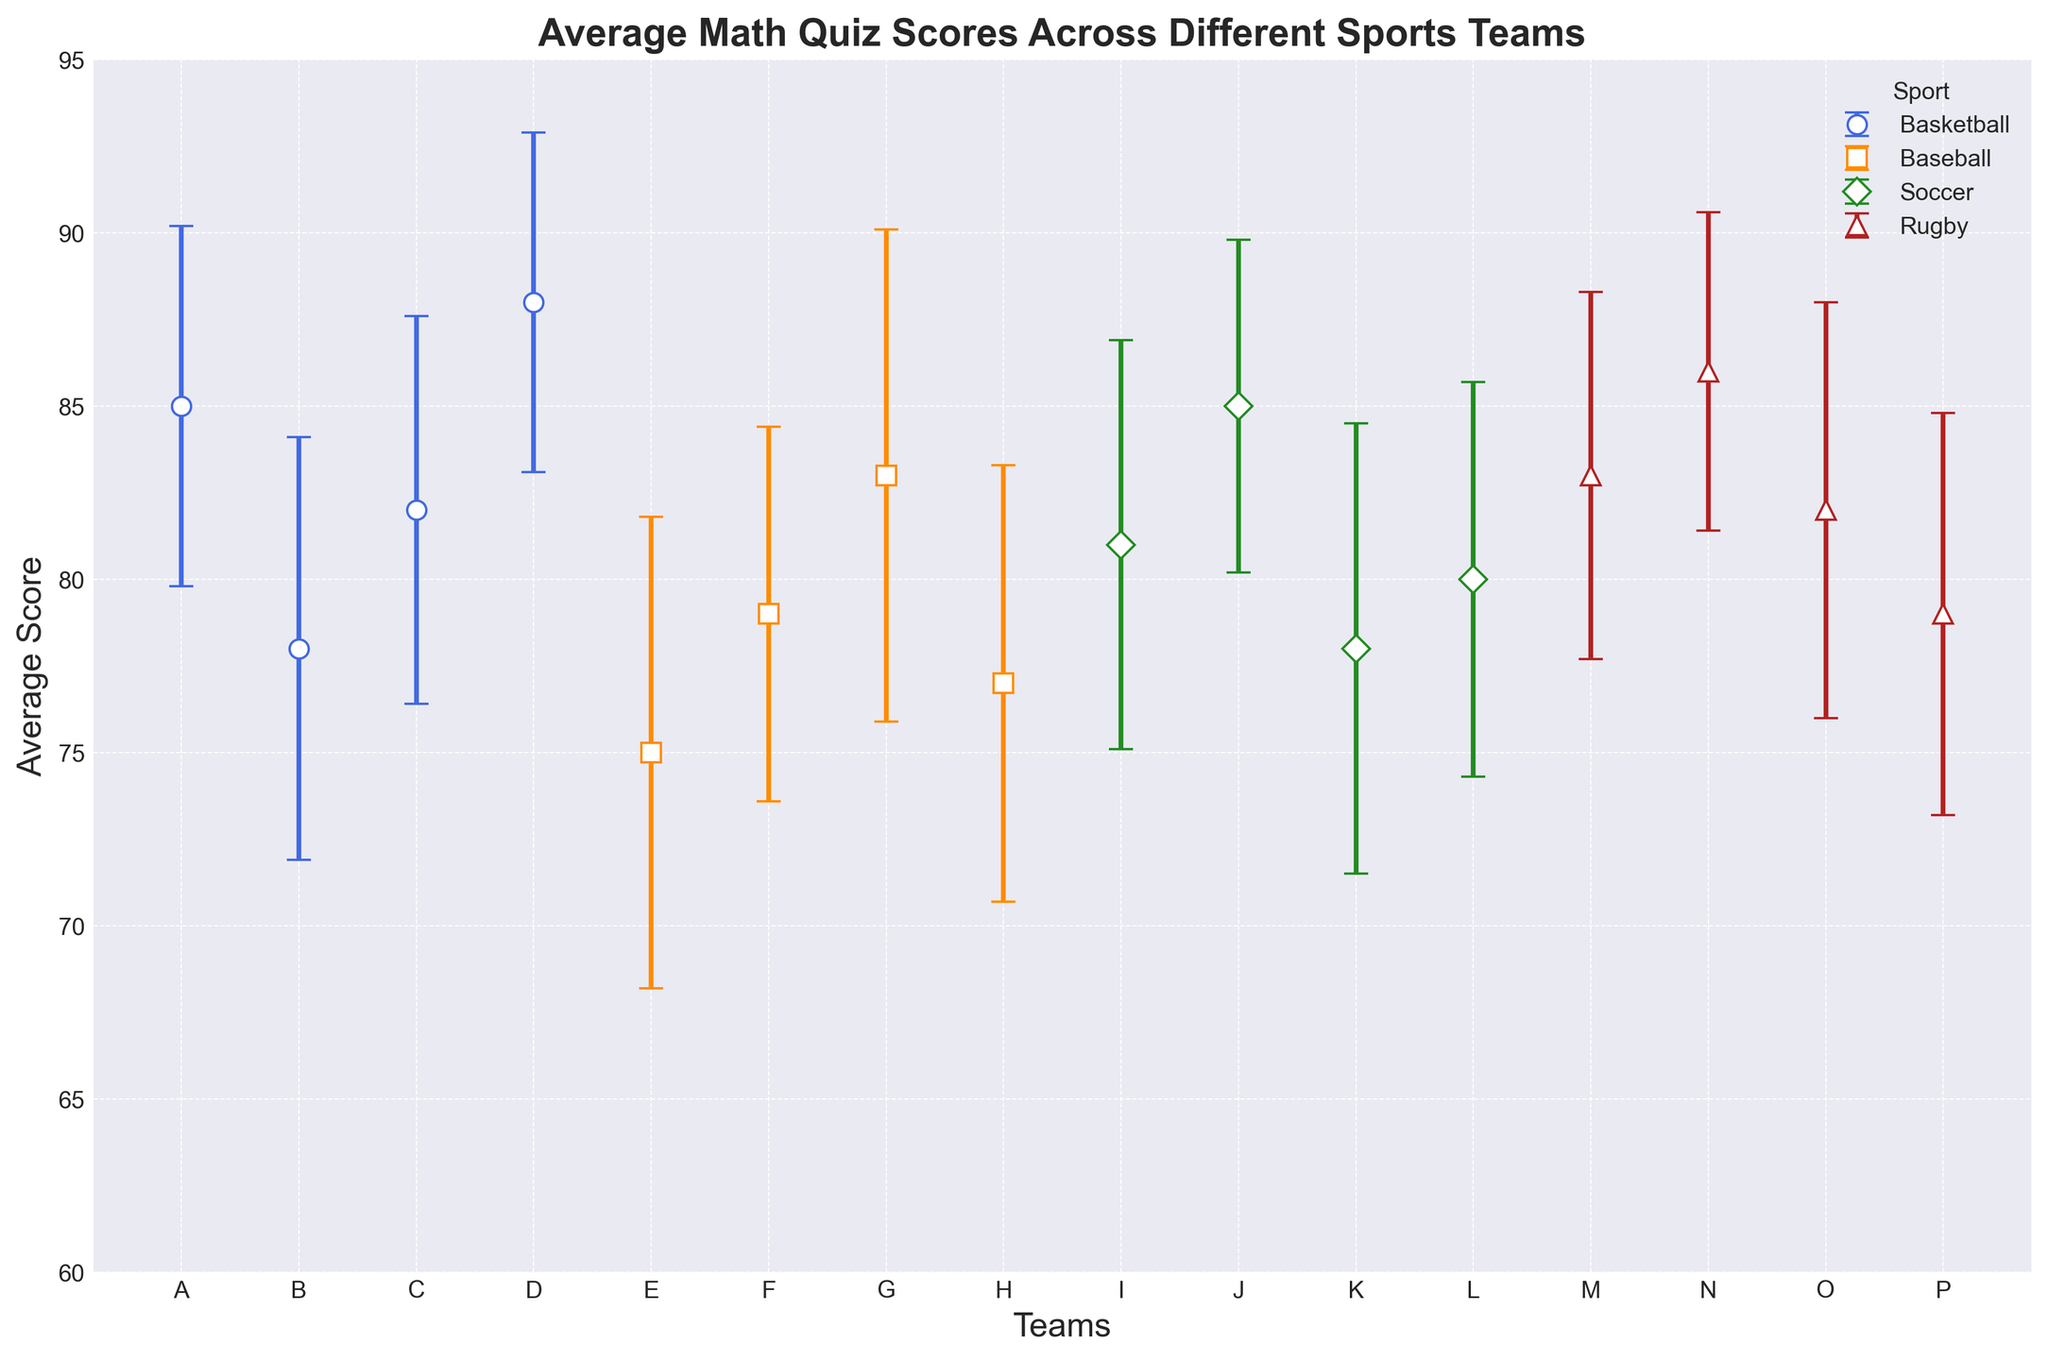Which sport has the team with the highest average score? The highest average score can be identified by looking for the tallest point in the figure. Team D from Basketball has the highest average score of 88.
Answer: Basketball Which sport shows the smallest variance in scores among its teams? The smallest variance corresponds to the smallest error bars. Rugby has the smallest error bars, indicating the least variance.
Answer: Rugby What is the difference between the highest and lowest average scores in Baseball? The highest average score in Baseball is 83 (Team G) and the lowest is 75 (Team E). The difference is 83 - 75 = 8.
Answer: 8 Comparing Team J and Team L in Soccer, which team has a higher average score, and by how much? Team J has an average score of 85; Team L's average score is 80. The difference is 85 - 80 = 5.
Answer: Team J, 5 Which team in Rugby has the highest average score? The highest average score in Rugby can be identified by looking for the tallest point among the Rugby teams. Team N has the highest average score of 86.
Answer: Team N Comparing all the sports, which team has the largest variance in their scores? The largest variance is indicated by the longest error bar. Team G from Baseball has the largest standard deviation of 7.1.
Answer: Team G What is the average score for Team B in Basketball, and how does it compare to Team F in Baseball? Team B's average score in Basketball is 78. Team F's average score in Baseball is also 79. To find the difference: 79 - 78 = 1.
Answer: Team F has a 1-point higher average score Between Team I and Team K in Soccer, which has a smaller variance? Team I has a standard deviation of 5.9, while Team K has a standard deviation of 6.5. Therefore, Team I has a smaller variance.
Answer: Team I How does the average score of the Rugby teams compare in terms of range to that of the Soccer teams? The range for Rugby is the difference between the highest (86, Team N) and lowest (79, Team P) average scores: 86 - 79 = 7. The range for Soccer is between the highest (85, Team J) and lowest (78, Team K) average scores: 85 - 78 = 7. Both sports have an equal range of 7.
Answer: Equal What is the average average score of Soccer teams? To find the average of the Soccer teams, add their average scores (81 + 85 + 78 + 80) = 324 and divide by the number of teams (4). 324 / 4 = 81.
Answer: 81 